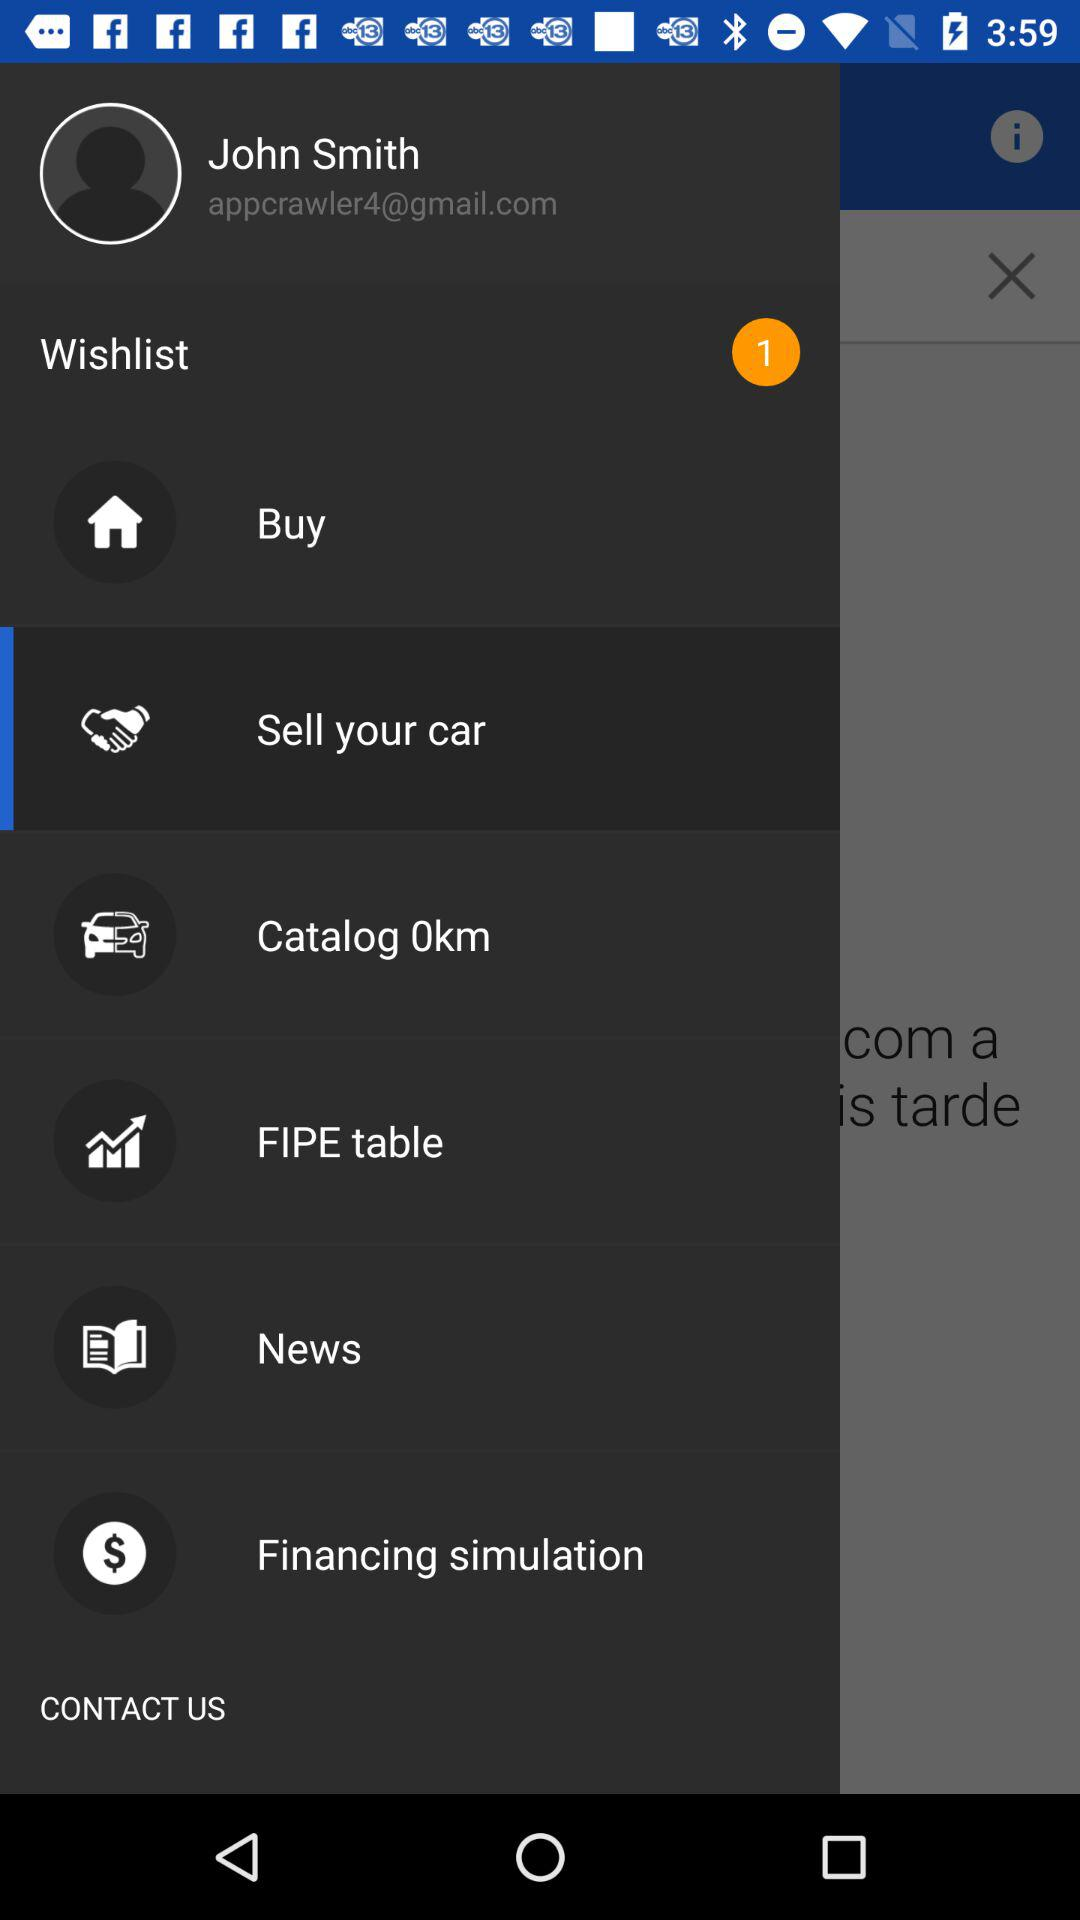How many items are in the wishlist? There is one item in the wishlist. 